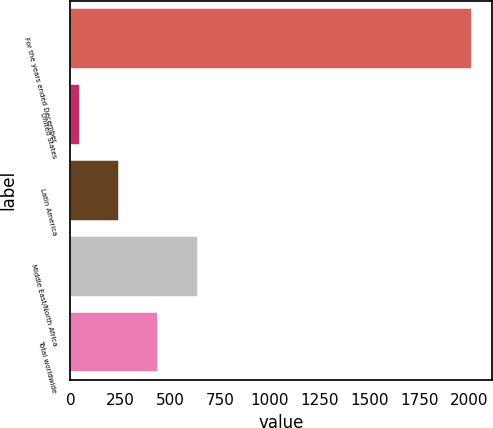Convert chart to OTSL. <chart><loc_0><loc_0><loc_500><loc_500><bar_chart><fcel>For the years ended December<fcel>United States<fcel>Latin America<fcel>Middle East/North Africa<fcel>Total worldwide<nl><fcel>2017<fcel>47.91<fcel>244.82<fcel>638.64<fcel>441.73<nl></chart> 